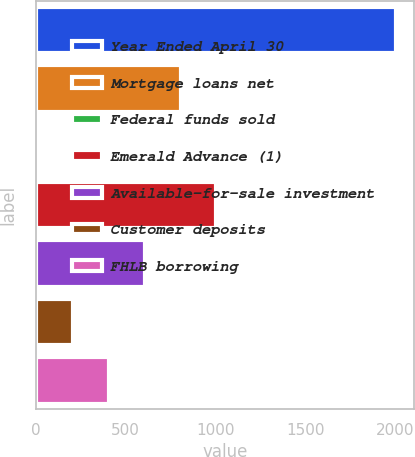Convert chart to OTSL. <chart><loc_0><loc_0><loc_500><loc_500><bar_chart><fcel>Year Ended April 30<fcel>Mortgage loans net<fcel>Federal funds sold<fcel>Emerald Advance (1)<fcel>Available-for-sale investment<fcel>Customer deposits<fcel>FHLB borrowing<nl><fcel>2008<fcel>805.15<fcel>3.25<fcel>1005.62<fcel>604.68<fcel>203.73<fcel>404.21<nl></chart> 